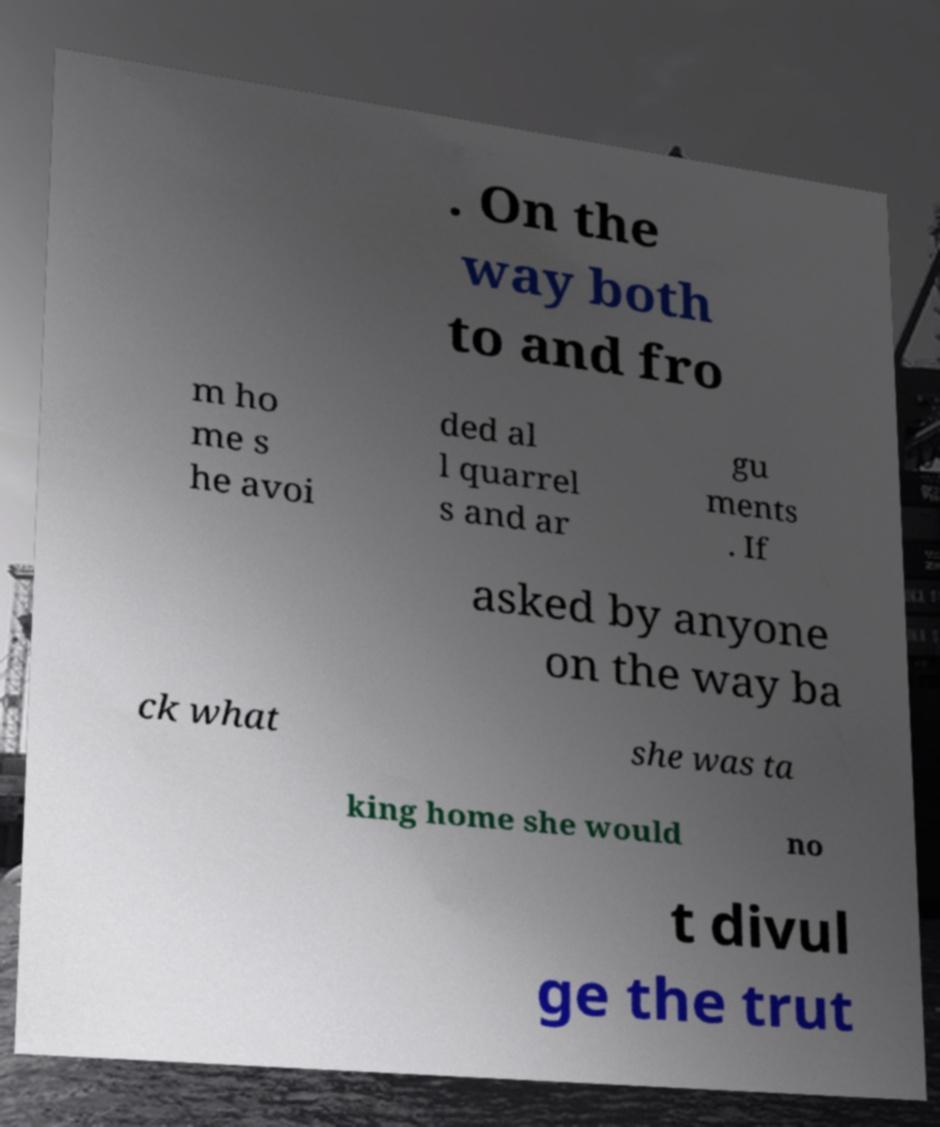There's text embedded in this image that I need extracted. Can you transcribe it verbatim? . On the way both to and fro m ho me s he avoi ded al l quarrel s and ar gu ments . If asked by anyone on the way ba ck what she was ta king home she would no t divul ge the trut 